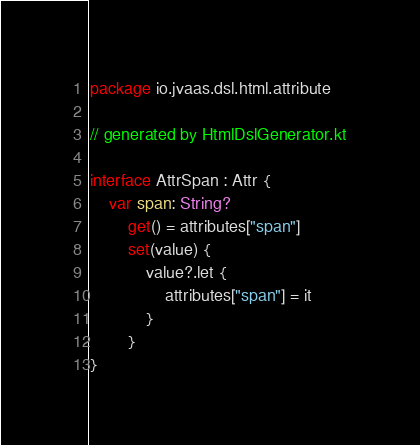Convert code to text. <code><loc_0><loc_0><loc_500><loc_500><_Kotlin_>package io.jvaas.dsl.html.attribute

// generated by HtmlDslGenerator.kt

interface AttrSpan : Attr {
	var span: String?
		get() = attributes["span"]
		set(value) {
			value?.let {
				attributes["span"] = it
			}
		}
}	
</code> 